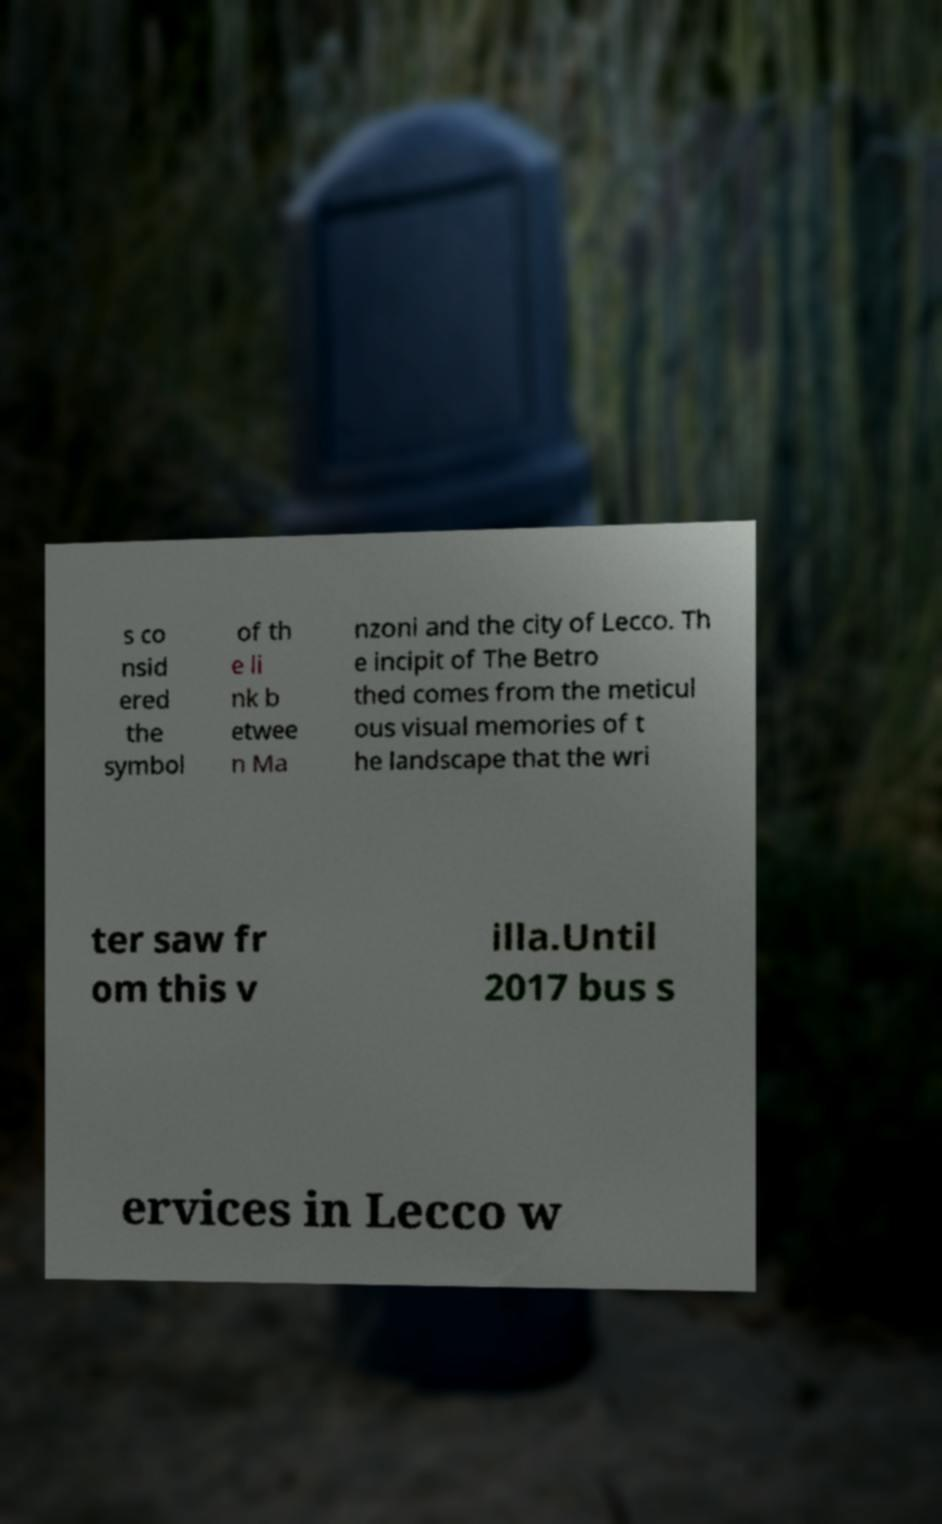Can you read and provide the text displayed in the image?This photo seems to have some interesting text. Can you extract and type it out for me? s co nsid ered the symbol of th e li nk b etwee n Ma nzoni and the city of Lecco. Th e incipit of The Betro thed comes from the meticul ous visual memories of t he landscape that the wri ter saw fr om this v illa.Until 2017 bus s ervices in Lecco w 